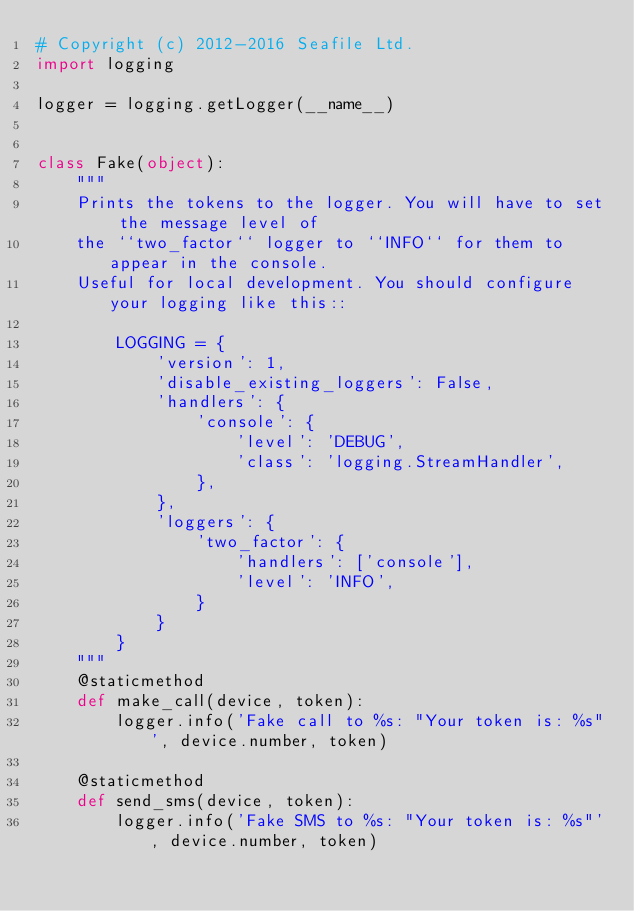<code> <loc_0><loc_0><loc_500><loc_500><_Python_># Copyright (c) 2012-2016 Seafile Ltd.
import logging

logger = logging.getLogger(__name__)


class Fake(object):
    """
    Prints the tokens to the logger. You will have to set the message level of
    the ``two_factor`` logger to ``INFO`` for them to appear in the console.
    Useful for local development. You should configure your logging like this::

        LOGGING = {
            'version': 1,
            'disable_existing_loggers': False,
            'handlers': {
                'console': {
                    'level': 'DEBUG',
                    'class': 'logging.StreamHandler',
                },
            },
            'loggers': {
                'two_factor': {
                    'handlers': ['console'],
                    'level': 'INFO',
                }
            }
        }
    """
    @staticmethod
    def make_call(device, token):
        logger.info('Fake call to %s: "Your token is: %s"', device.number, token)

    @staticmethod
    def send_sms(device, token):
        logger.info('Fake SMS to %s: "Your token is: %s"', device.number, token)
</code> 